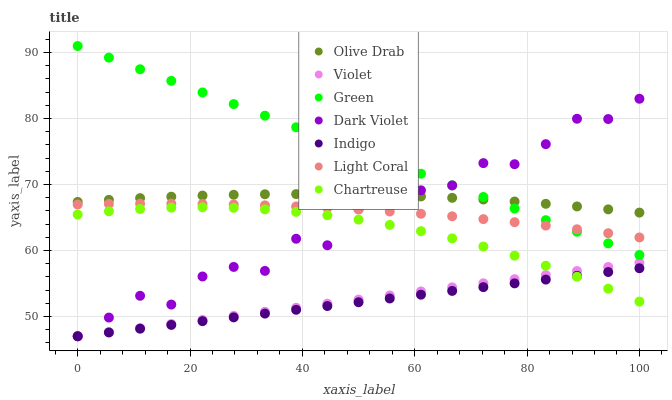Does Indigo have the minimum area under the curve?
Answer yes or no. Yes. Does Green have the maximum area under the curve?
Answer yes or no. Yes. Does Dark Violet have the minimum area under the curve?
Answer yes or no. No. Does Dark Violet have the maximum area under the curve?
Answer yes or no. No. Is Violet the smoothest?
Answer yes or no. Yes. Is Dark Violet the roughest?
Answer yes or no. Yes. Is Light Coral the smoothest?
Answer yes or no. No. Is Light Coral the roughest?
Answer yes or no. No. Does Indigo have the lowest value?
Answer yes or no. Yes. Does Light Coral have the lowest value?
Answer yes or no. No. Does Green have the highest value?
Answer yes or no. Yes. Does Dark Violet have the highest value?
Answer yes or no. No. Is Indigo less than Olive Drab?
Answer yes or no. Yes. Is Green greater than Violet?
Answer yes or no. Yes. Does Dark Violet intersect Olive Drab?
Answer yes or no. Yes. Is Dark Violet less than Olive Drab?
Answer yes or no. No. Is Dark Violet greater than Olive Drab?
Answer yes or no. No. Does Indigo intersect Olive Drab?
Answer yes or no. No. 